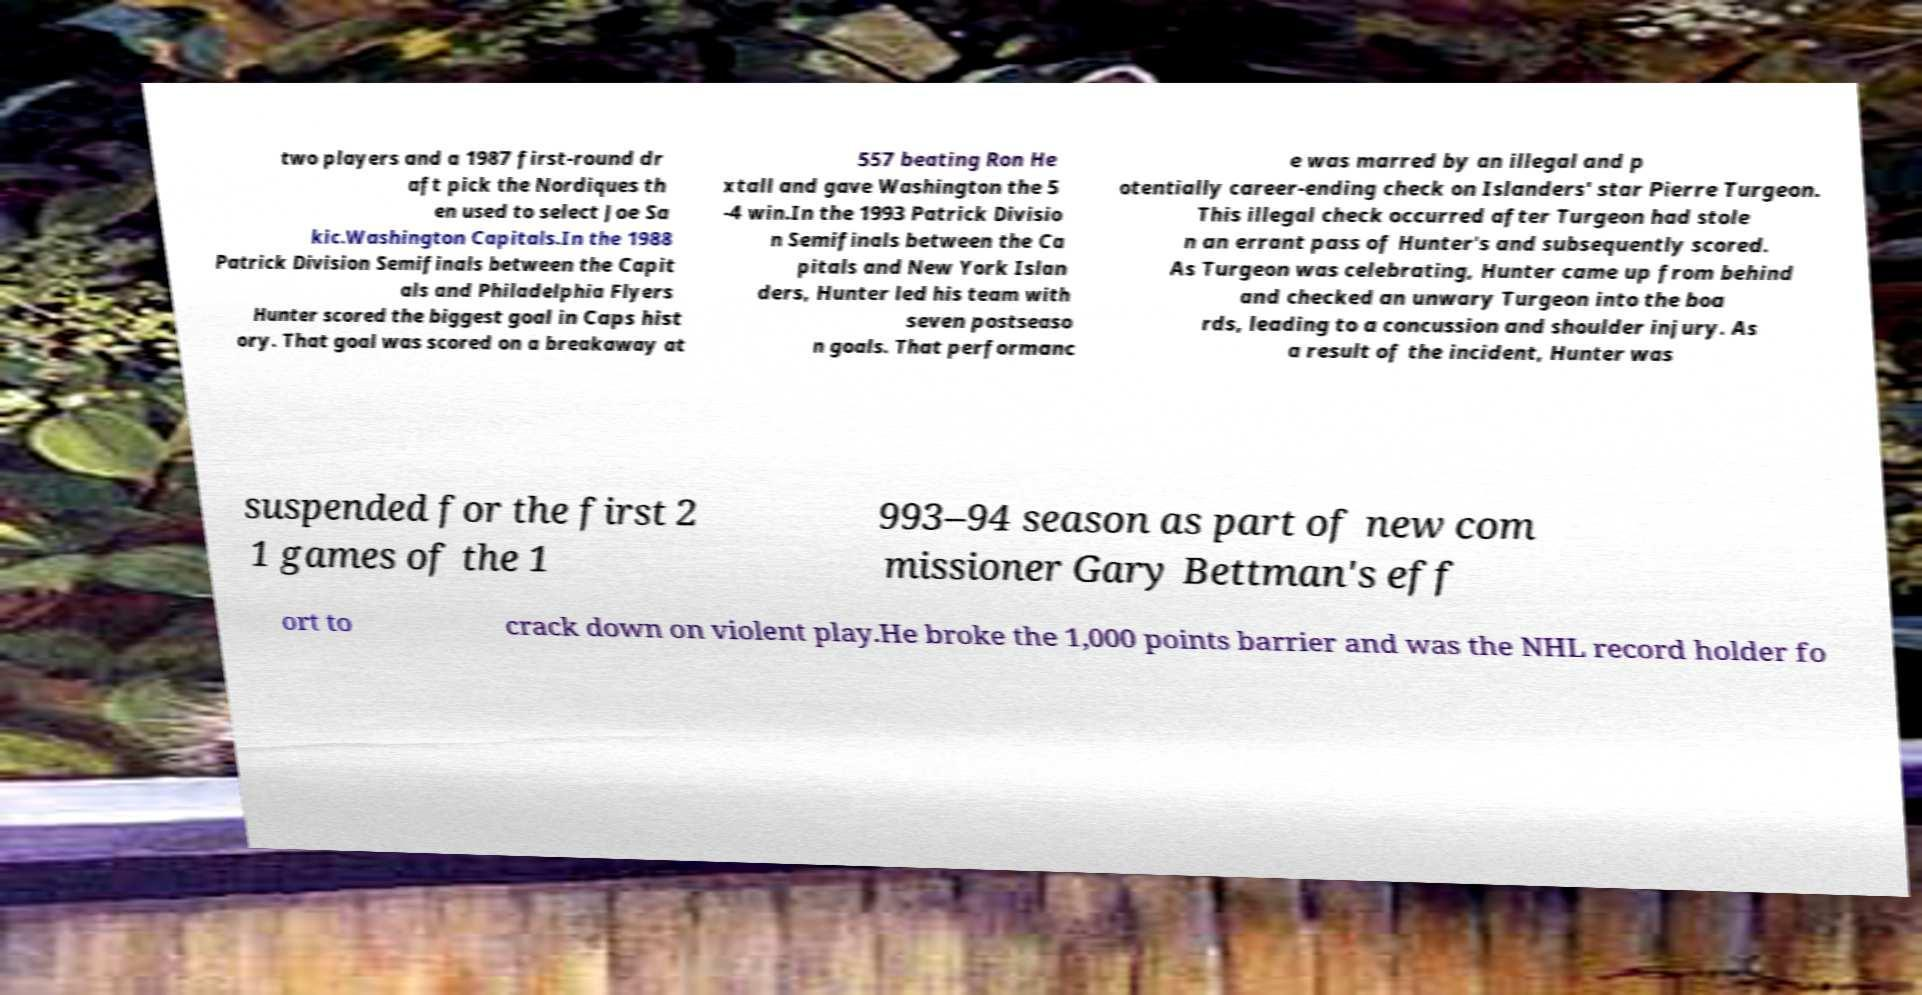Could you extract and type out the text from this image? two players and a 1987 first-round dr aft pick the Nordiques th en used to select Joe Sa kic.Washington Capitals.In the 1988 Patrick Division Semifinals between the Capit als and Philadelphia Flyers Hunter scored the biggest goal in Caps hist ory. That goal was scored on a breakaway at 557 beating Ron He xtall and gave Washington the 5 -4 win.In the 1993 Patrick Divisio n Semifinals between the Ca pitals and New York Islan ders, Hunter led his team with seven postseaso n goals. That performanc e was marred by an illegal and p otentially career-ending check on Islanders' star Pierre Turgeon. This illegal check occurred after Turgeon had stole n an errant pass of Hunter's and subsequently scored. As Turgeon was celebrating, Hunter came up from behind and checked an unwary Turgeon into the boa rds, leading to a concussion and shoulder injury. As a result of the incident, Hunter was suspended for the first 2 1 games of the 1 993–94 season as part of new com missioner Gary Bettman's eff ort to crack down on violent play.He broke the 1,000 points barrier and was the NHL record holder fo 